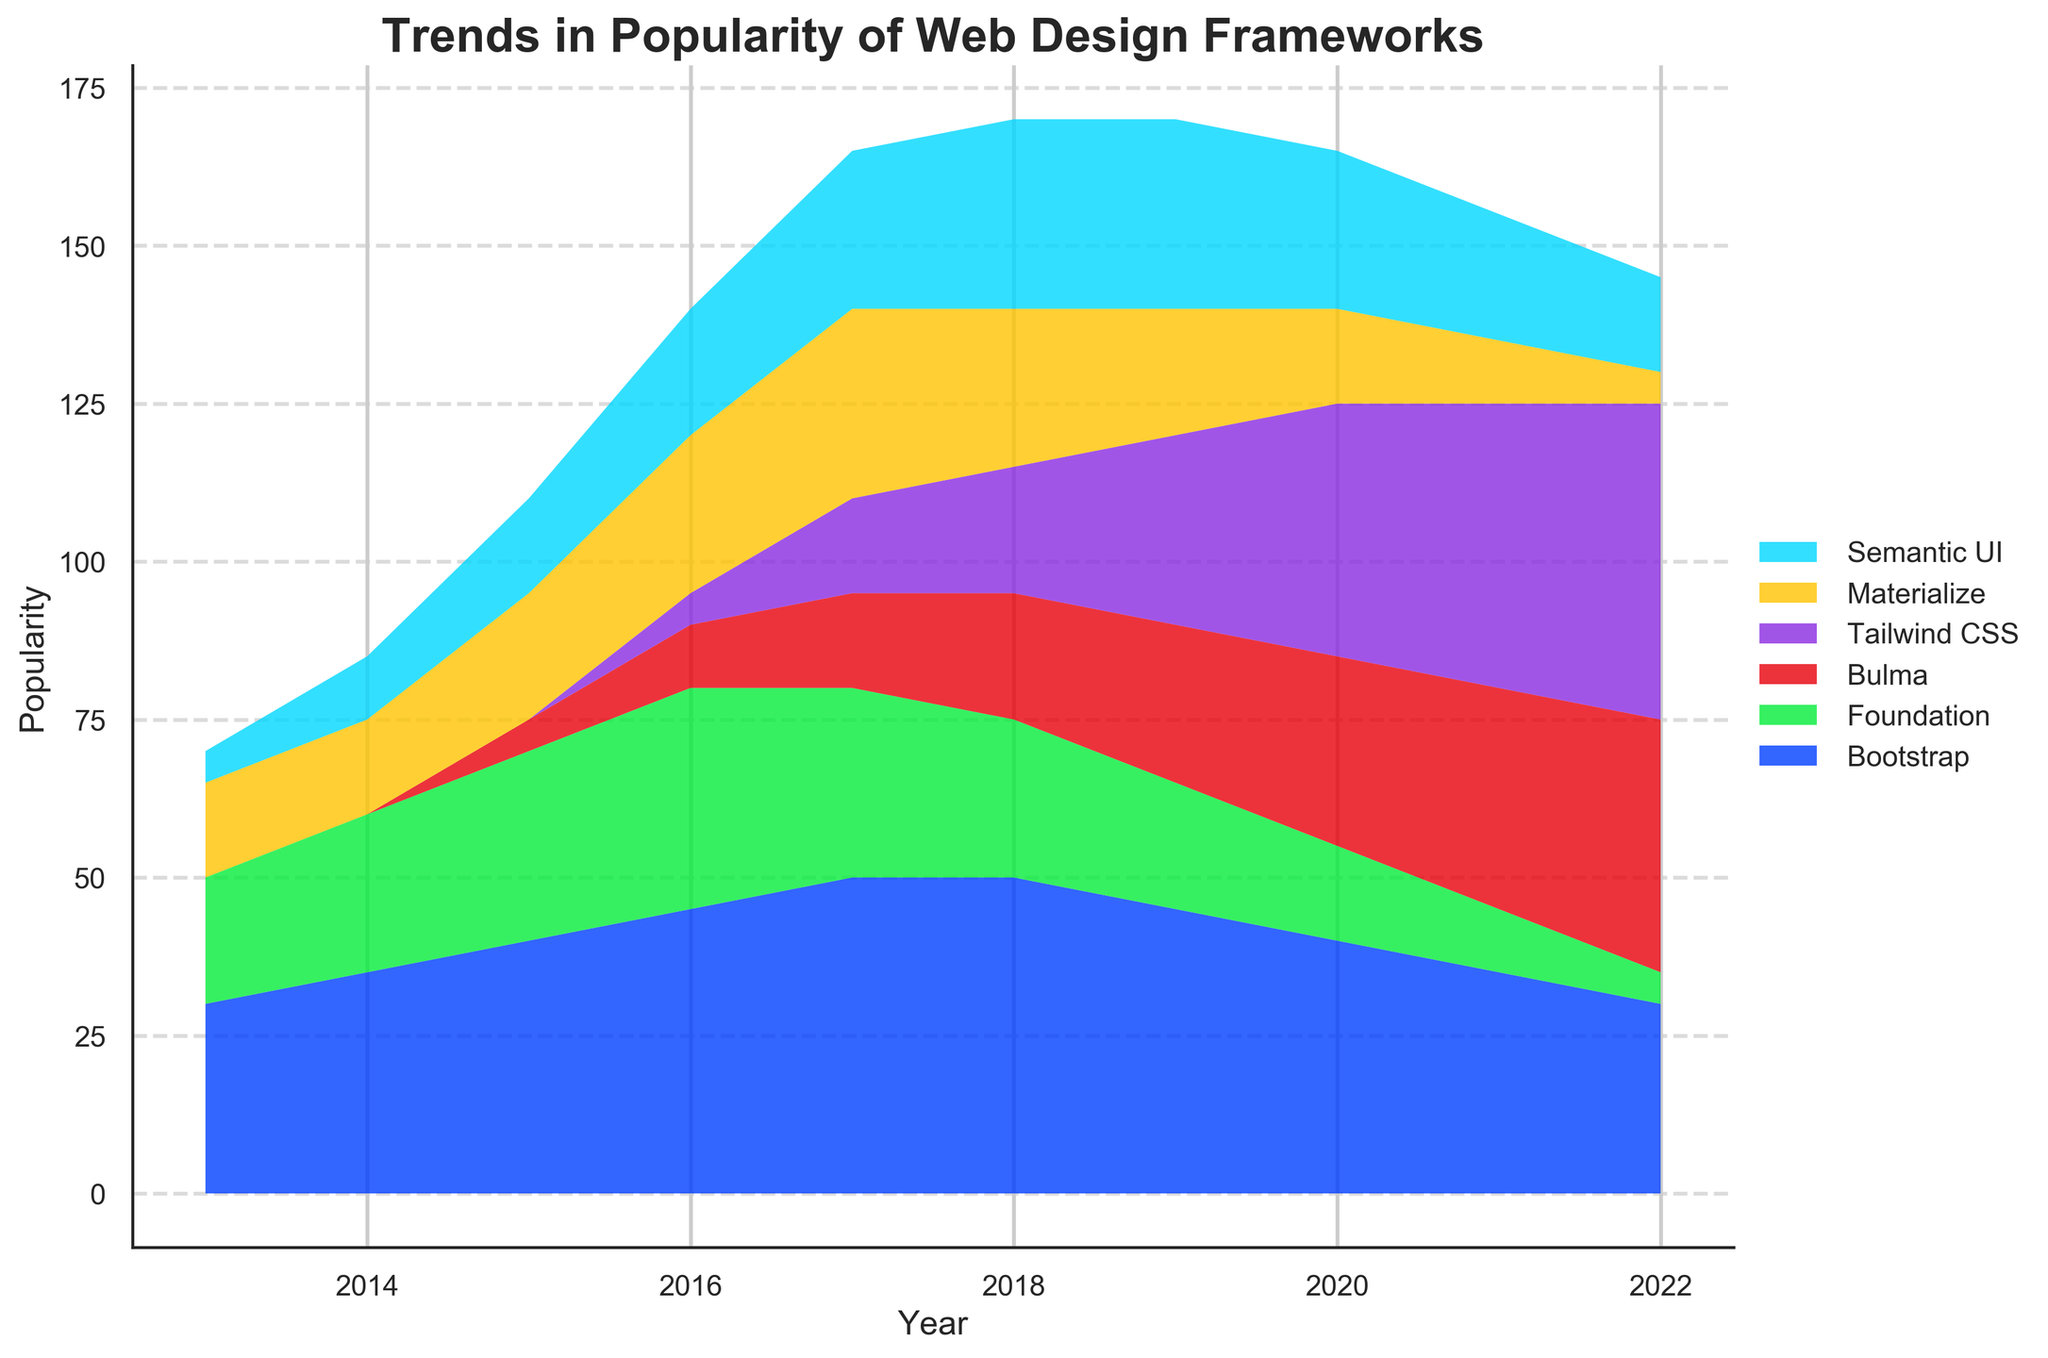What is the title of the figure? The title can be found at the top of the figure. It is "Trends in Popularity of Web Design Frameworks".
Answer: Trends in Popularity of Web Design Frameworks How many web design frameworks are displayed in the figure? By observing the different colored areas in the stream graph and the legend labels, we can count six distinct frameworks.
Answer: Six In which year did Tailwind CSS start showing popularity according to the graph? By looking at the stream graph, we see Tailwind CSS starts to appear as a visible section of the graph in 2016.
Answer: 2016 Which framework had the highest popularity in 2017? In 2017, the area representing Bootstrap is the largest, indicating it had the highest popularity.
Answer: Bootstrap What is the trend of popularity for Semantic UI from 2013 to 2022? By examining the filled area representing Semantic UI, it appears to steadily increase from 2013 to 2018, maintain a high level until 2020, and then decrease slightly afterward.
Answer: Increase until 2018, remain high until 2020, then decrease Which frameworks have shown a consistent decrease in popularity from 2013 to 2022? By looking at each framework's area, both Foundation and Materialize show a continuous decrease in popularity throughout the decade.
Answer: Foundation and Materialize In which year were the popularity levels for Bootstrap and Tailwind CSS equal? From the graph, we can see that in 2021, the areas for Bootstrap and Tailwind CSS are approximately the same size.
Answer: 2021 In which year did Bulma first appear, and at what approximate popularity level? Bulma first appears in the year 2015 and starts at an approximate popularity level of 5.
Answer: 2015, 5 Which framework showed the most consistent increase in popularity over the entire decade? Tailwind CSS shows a consistent increase in its area from its appearance in 2016 through to 2022, rising yearly.
Answer: Tailwind CSS What was the approximate combined popularity of Bootstrap and Foundation in 2020? In 2020, Bootstrap had a popularity of 40 and Foundation had 15. Summing these values gives us 55.
Answer: 55 